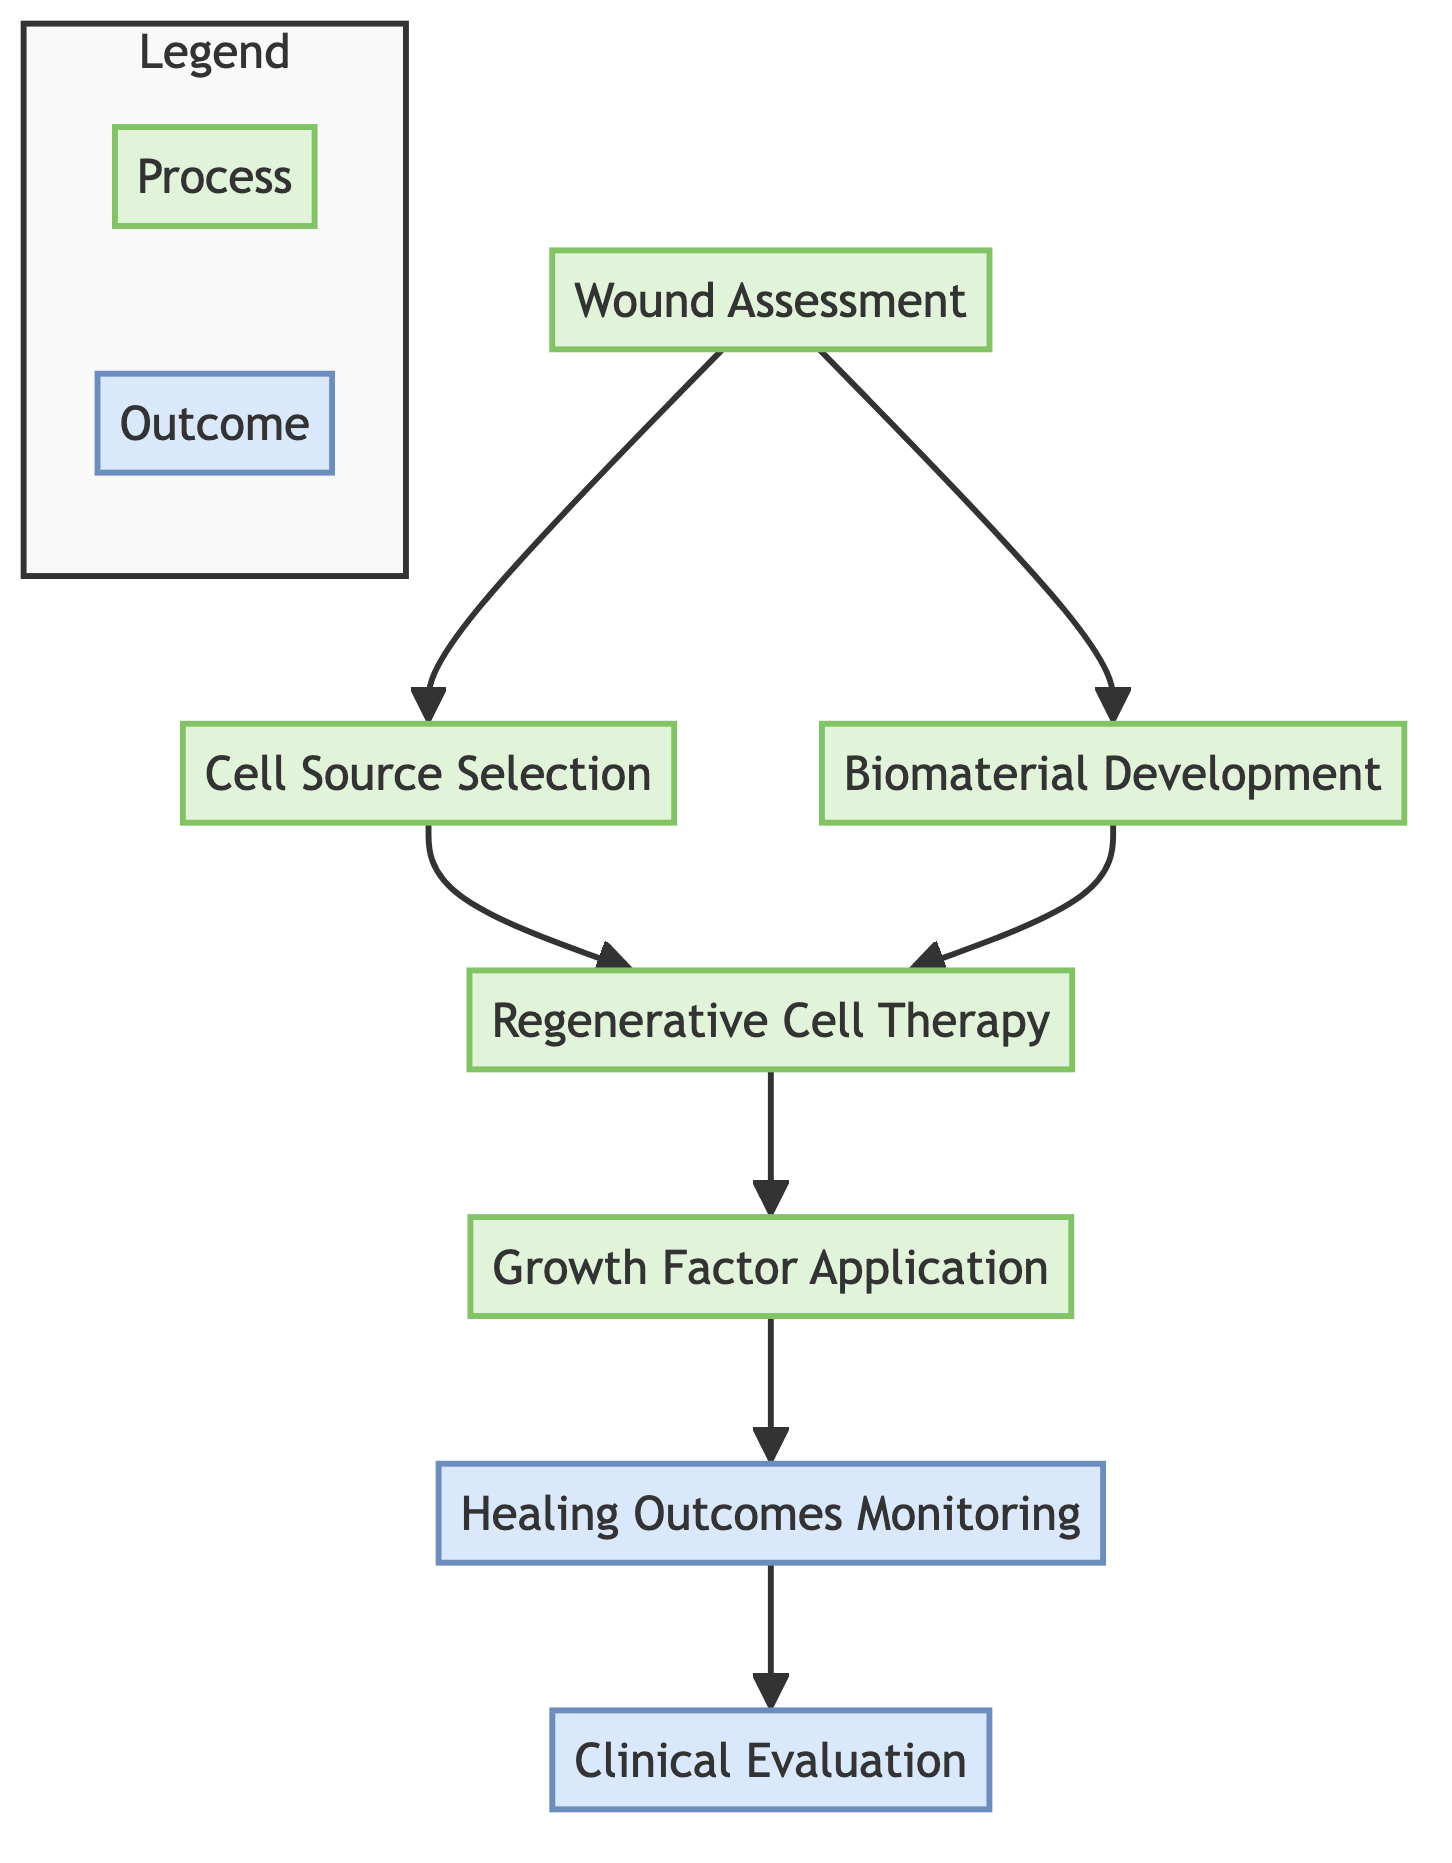What is the first step in the process? The process begins with "Wound Assessment," which is indicated as the initial node in the flow.
Answer: Wound Assessment How many total nodes are in the diagram? Counting each distinct element in the flow, there are six nodes that represent different steps in the process.
Answer: Six What follows "Cell Source Selection" in the flow? The next step after "Cell Source Selection" is "Regenerative Cell Therapy," which directly connects to it in the diagram.
Answer: Regenerative Cell Therapy Which two processes lead into "Regenerative Cell Therapy"? The two processes leading into "Regenerative Cell Therapy" are "Cell Source Selection" and "Biomaterial Development," as shown by the connections from both nodes.
Answer: Cell Source Selection and Biomaterial Development What type of evaluation is represented at the end of the flowchart? The evaluation indicated at the end of the flowchart is "Clinical Evaluation," which serves as an outcome step after monitoring healing outcomes.
Answer: Clinical Evaluation How does "Growth Factor Application" relate to "Healing Outcomes Monitoring"? "Growth Factor Application" is directly connected to "Healing Outcomes Monitoring," indicating it is a precursor step that supports the healing process and leads into monitoring.
Answer: Directly connected Which elements are categorized as process nodes? The process nodes identified in the diagram are "Wound Assessment," "Cell Source Selection," "Biomaterial Development," "Regenerative Cell Therapy," and "Growth Factor Application."
Answer: Five nodes What leads to the final outcome in the flowchart? The final outcome, "Clinical Evaluation," is reached after "Healing Outcomes Monitoring," which shows that monitoring is necessary before evaluation can occur.
Answer: Healing Outcomes Monitoring Does "Growth Factor Application" have any subsequent steps? Yes, "Growth Factor Application" leads to "Healing Outcomes Monitoring," indicating that it is a part of the overall process flow and has a subsequent step.
Answer: Yes 